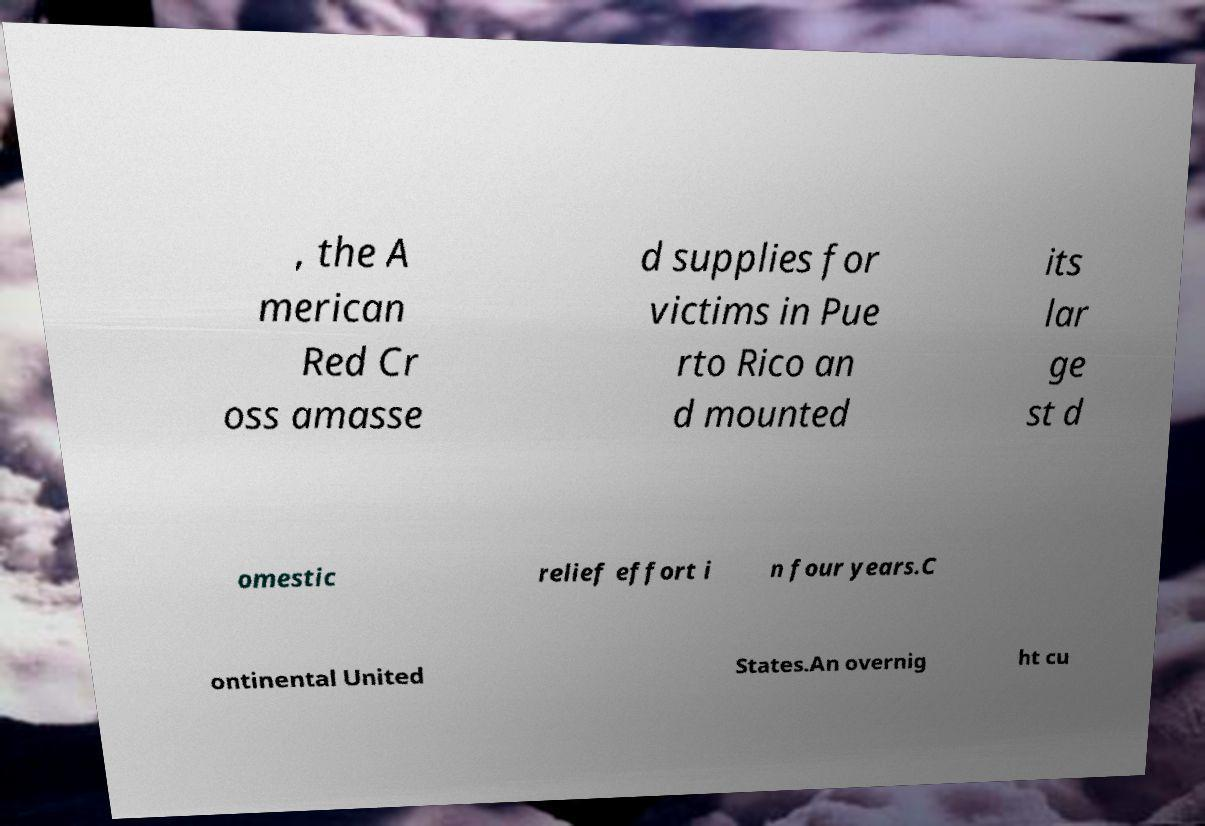For documentation purposes, I need the text within this image transcribed. Could you provide that? , the A merican Red Cr oss amasse d supplies for victims in Pue rto Rico an d mounted its lar ge st d omestic relief effort i n four years.C ontinental United States.An overnig ht cu 